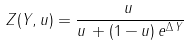Convert formula to latex. <formula><loc_0><loc_0><loc_500><loc_500>Z ( Y , u ) = \frac { u \, } { u \, + ( 1 - u ) \, e ^ { \Delta \, Y } }</formula> 